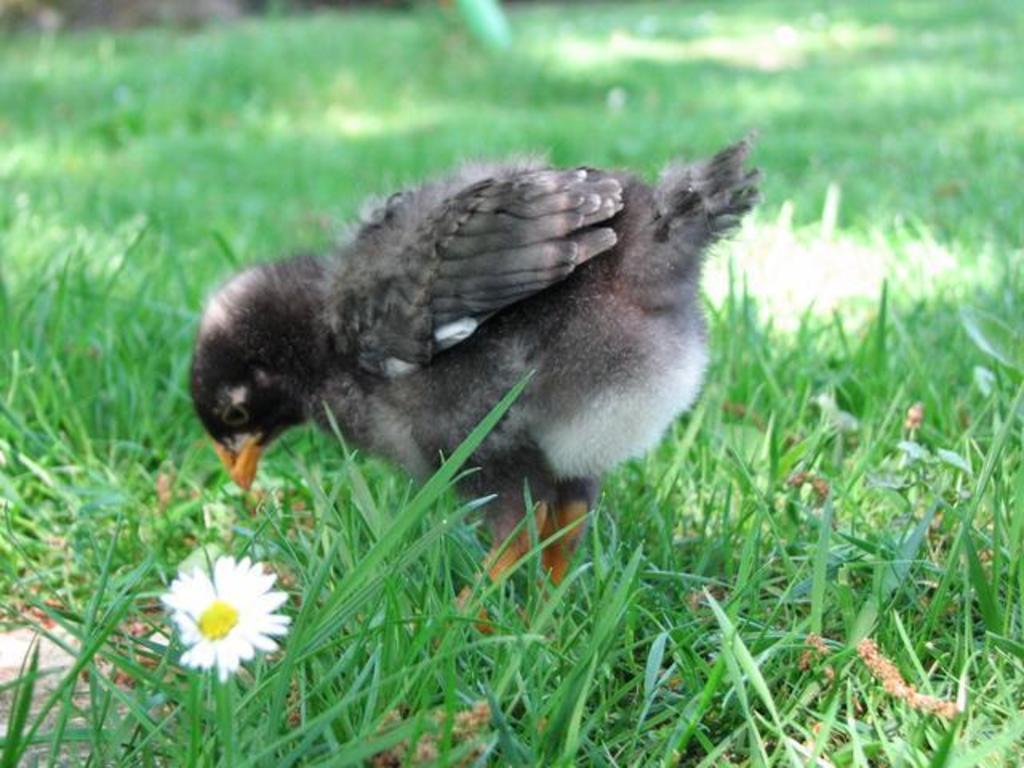What type of animal can be seen in the picture? There is a bird in the picture. What type of vegetation is present in the picture? There is grass in the picture. What other object can be seen on the floor in the picture? There is a flower on the floor in the picture. How would you describe the background of the image? The backdrop of the image is blurred. What type of lettuce is the bird eating in the picture? There is no lettuce present in the image, and the bird is not shown eating anything. 